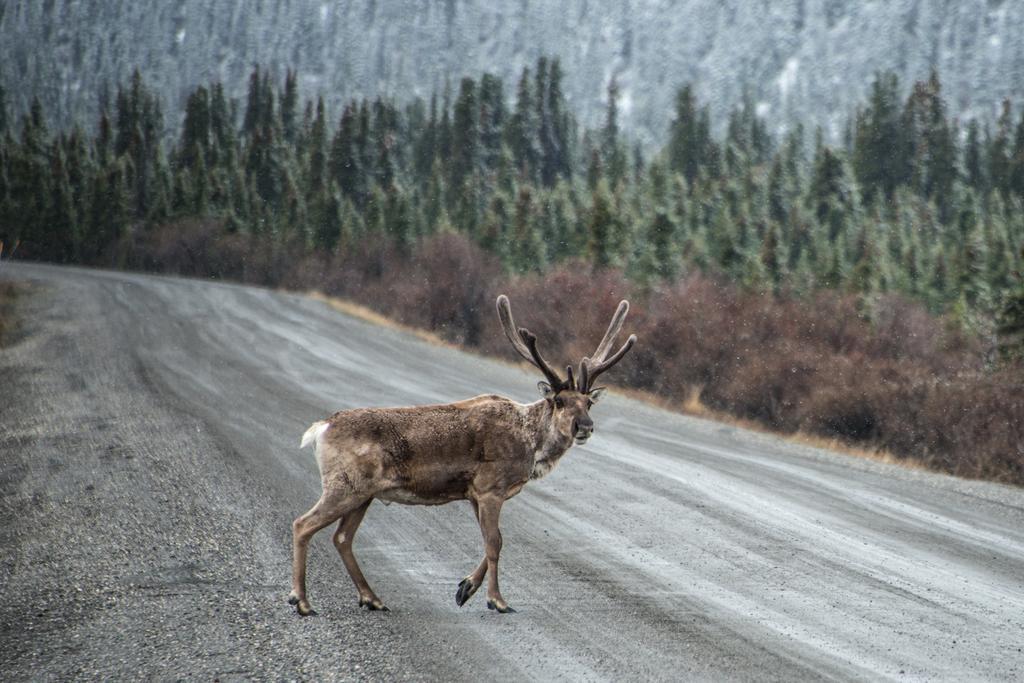How would you summarize this image in a sentence or two? In this picture there is a deer in the center of the image and there are trees in the background area of the image. 